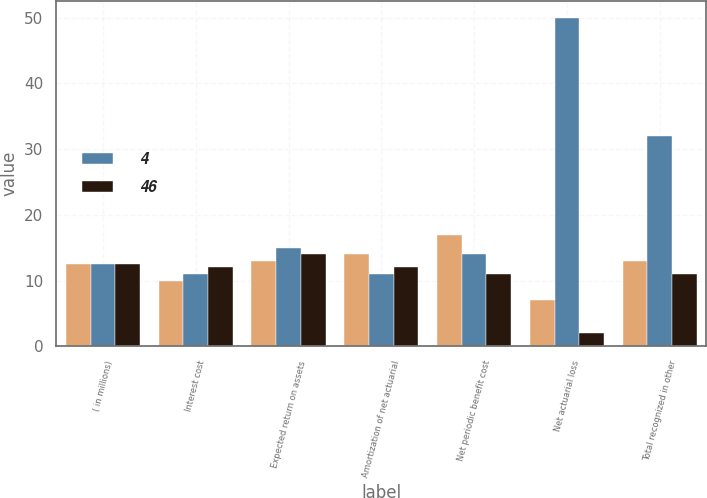<chart> <loc_0><loc_0><loc_500><loc_500><stacked_bar_chart><ecel><fcel>( in millions)<fcel>Interest cost<fcel>Expected return on assets<fcel>Amortization of net actuarial<fcel>Net periodic benefit cost<fcel>Net actuarial loss<fcel>Total recognized in other<nl><fcel>nan<fcel>12.5<fcel>10<fcel>13<fcel>14<fcel>17<fcel>7<fcel>13<nl><fcel>4<fcel>12.5<fcel>11<fcel>15<fcel>11<fcel>14<fcel>50<fcel>32<nl><fcel>46<fcel>12.5<fcel>12<fcel>14<fcel>12<fcel>11<fcel>2<fcel>11<nl></chart> 